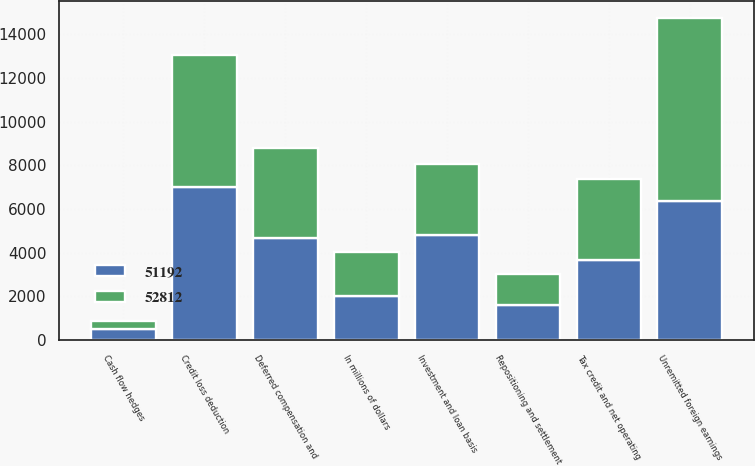Convert chart to OTSL. <chart><loc_0><loc_0><loc_500><loc_500><stacked_bar_chart><ecel><fcel>In millions of dollars<fcel>Credit loss deduction<fcel>Deferred compensation and<fcel>Repositioning and settlement<fcel>Unremitted foreign earnings<fcel>Investment and loan basis<fcel>Cash flow hedges<fcel>Tax credit and net operating<nl><fcel>52812<fcel>2015<fcel>6058<fcel>4110<fcel>1429<fcel>8403<fcel>3248<fcel>359<fcel>3679<nl><fcel>51192<fcel>2014<fcel>7010<fcel>4676<fcel>1599<fcel>6368<fcel>4808<fcel>529<fcel>3679<nl></chart> 